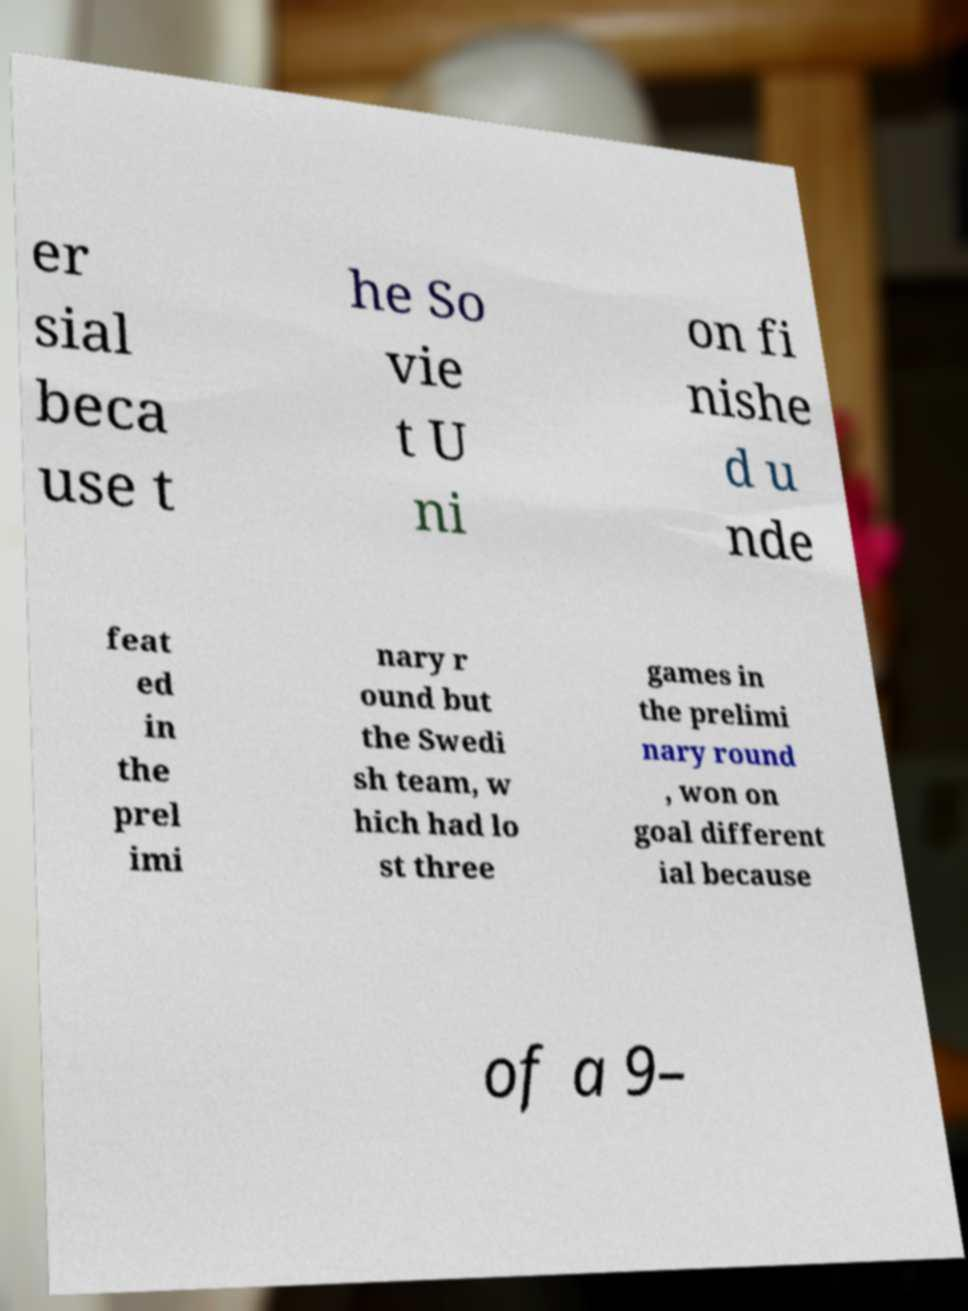Could you assist in decoding the text presented in this image and type it out clearly? er sial beca use t he So vie t U ni on fi nishe d u nde feat ed in the prel imi nary r ound but the Swedi sh team, w hich had lo st three games in the prelimi nary round , won on goal different ial because of a 9– 